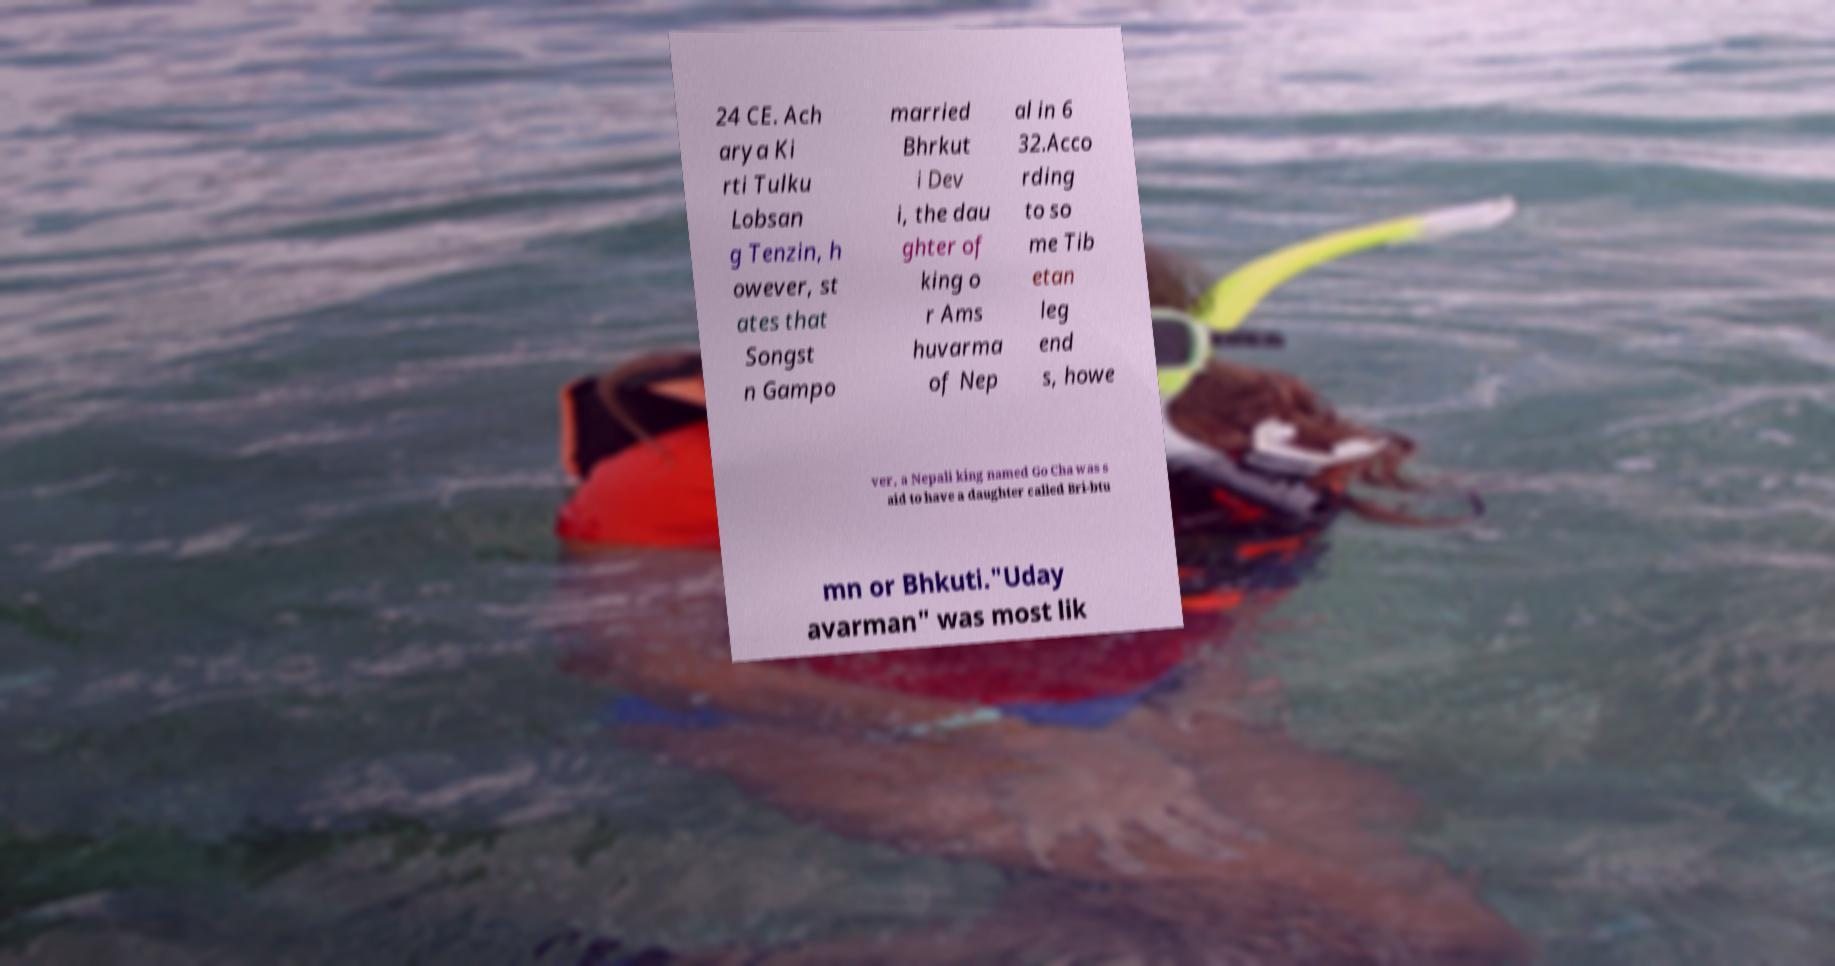There's text embedded in this image that I need extracted. Can you transcribe it verbatim? 24 CE. Ach arya Ki rti Tulku Lobsan g Tenzin, h owever, st ates that Songst n Gampo married Bhrkut i Dev i, the dau ghter of king o r Ams huvarma of Nep al in 6 32.Acco rding to so me Tib etan leg end s, howe ver, a Nepali king named Go Cha was s aid to have a daughter called Bri-btu mn or Bhkuti."Uday avarman" was most lik 